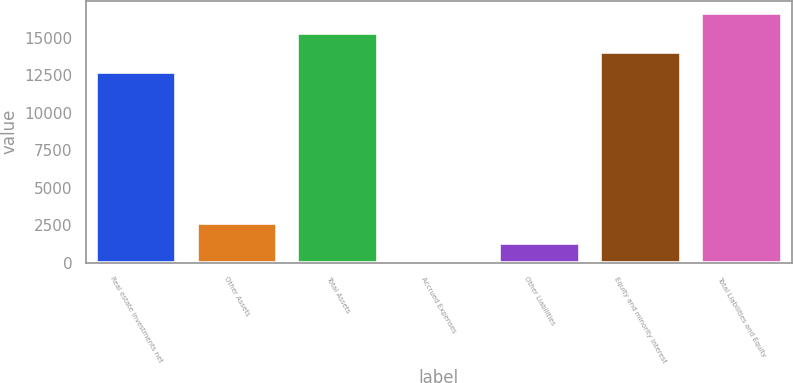Convert chart to OTSL. <chart><loc_0><loc_0><loc_500><loc_500><bar_chart><fcel>Real estate investments net<fcel>Other Assets<fcel>Total Assets<fcel>Accrued Expenses<fcel>Other Liabilities<fcel>Equity and minority interest<fcel>Total Liabilities and Equity<nl><fcel>12699<fcel>2642.4<fcel>15321.4<fcel>20<fcel>1331.2<fcel>14010.2<fcel>16632.6<nl></chart> 